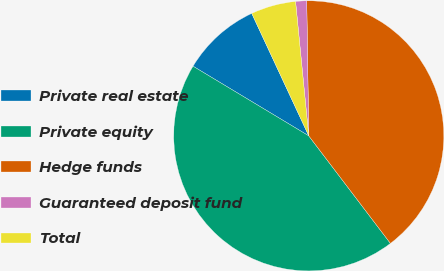Convert chart. <chart><loc_0><loc_0><loc_500><loc_500><pie_chart><fcel>Private real estate<fcel>Private equity<fcel>Hedge funds<fcel>Guaranteed deposit fund<fcel>Total<nl><fcel>9.44%<fcel>43.96%<fcel>39.9%<fcel>1.32%<fcel>5.38%<nl></chart> 